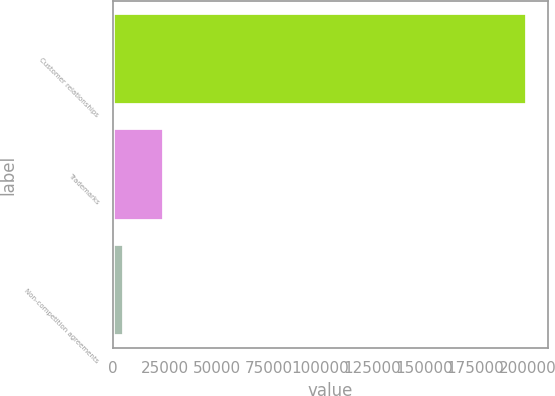<chart> <loc_0><loc_0><loc_500><loc_500><bar_chart><fcel>Customer relationships<fcel>Trademarks<fcel>Non-competition agreements<nl><fcel>199741<fcel>24520.9<fcel>5052<nl></chart> 